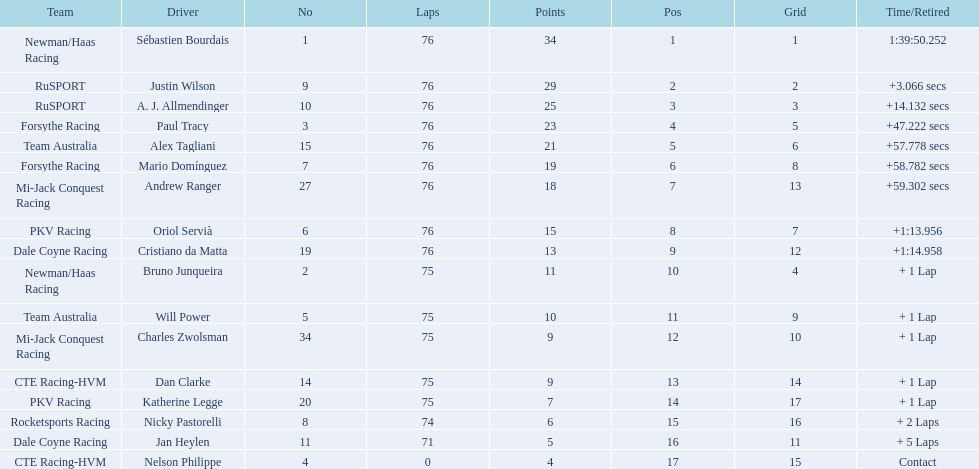Which drivers completed all 76 laps? Sébastien Bourdais, Justin Wilson, A. J. Allmendinger, Paul Tracy, Alex Tagliani, Mario Domínguez, Andrew Ranger, Oriol Servià, Cristiano da Matta. Of these drivers, which ones finished less than a minute behind first place? Paul Tracy, Alex Tagliani, Mario Domínguez, Andrew Ranger. Of these drivers, which ones finished with a time less than 50 seconds behind first place? Justin Wilson, A. J. Allmendinger, Paul Tracy. Of these three drivers, who finished last? Paul Tracy. 